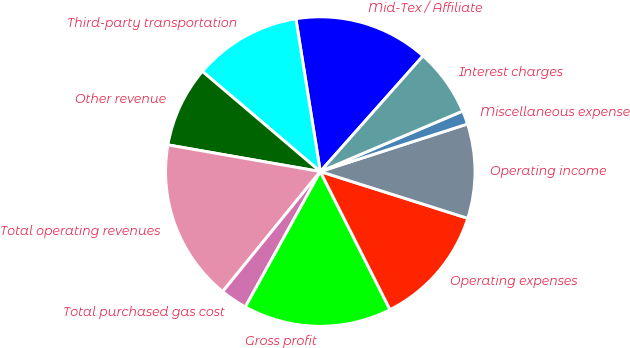<chart> <loc_0><loc_0><loc_500><loc_500><pie_chart><fcel>Mid-Tex / Affiliate<fcel>Third-party transportation<fcel>Other revenue<fcel>Total operating revenues<fcel>Total purchased gas cost<fcel>Gross profit<fcel>Operating expenses<fcel>Operating income<fcel>Miscellaneous expense<fcel>Interest charges<nl><fcel>14.08%<fcel>11.27%<fcel>8.45%<fcel>16.89%<fcel>2.82%<fcel>15.49%<fcel>12.67%<fcel>9.86%<fcel>1.42%<fcel>7.05%<nl></chart> 